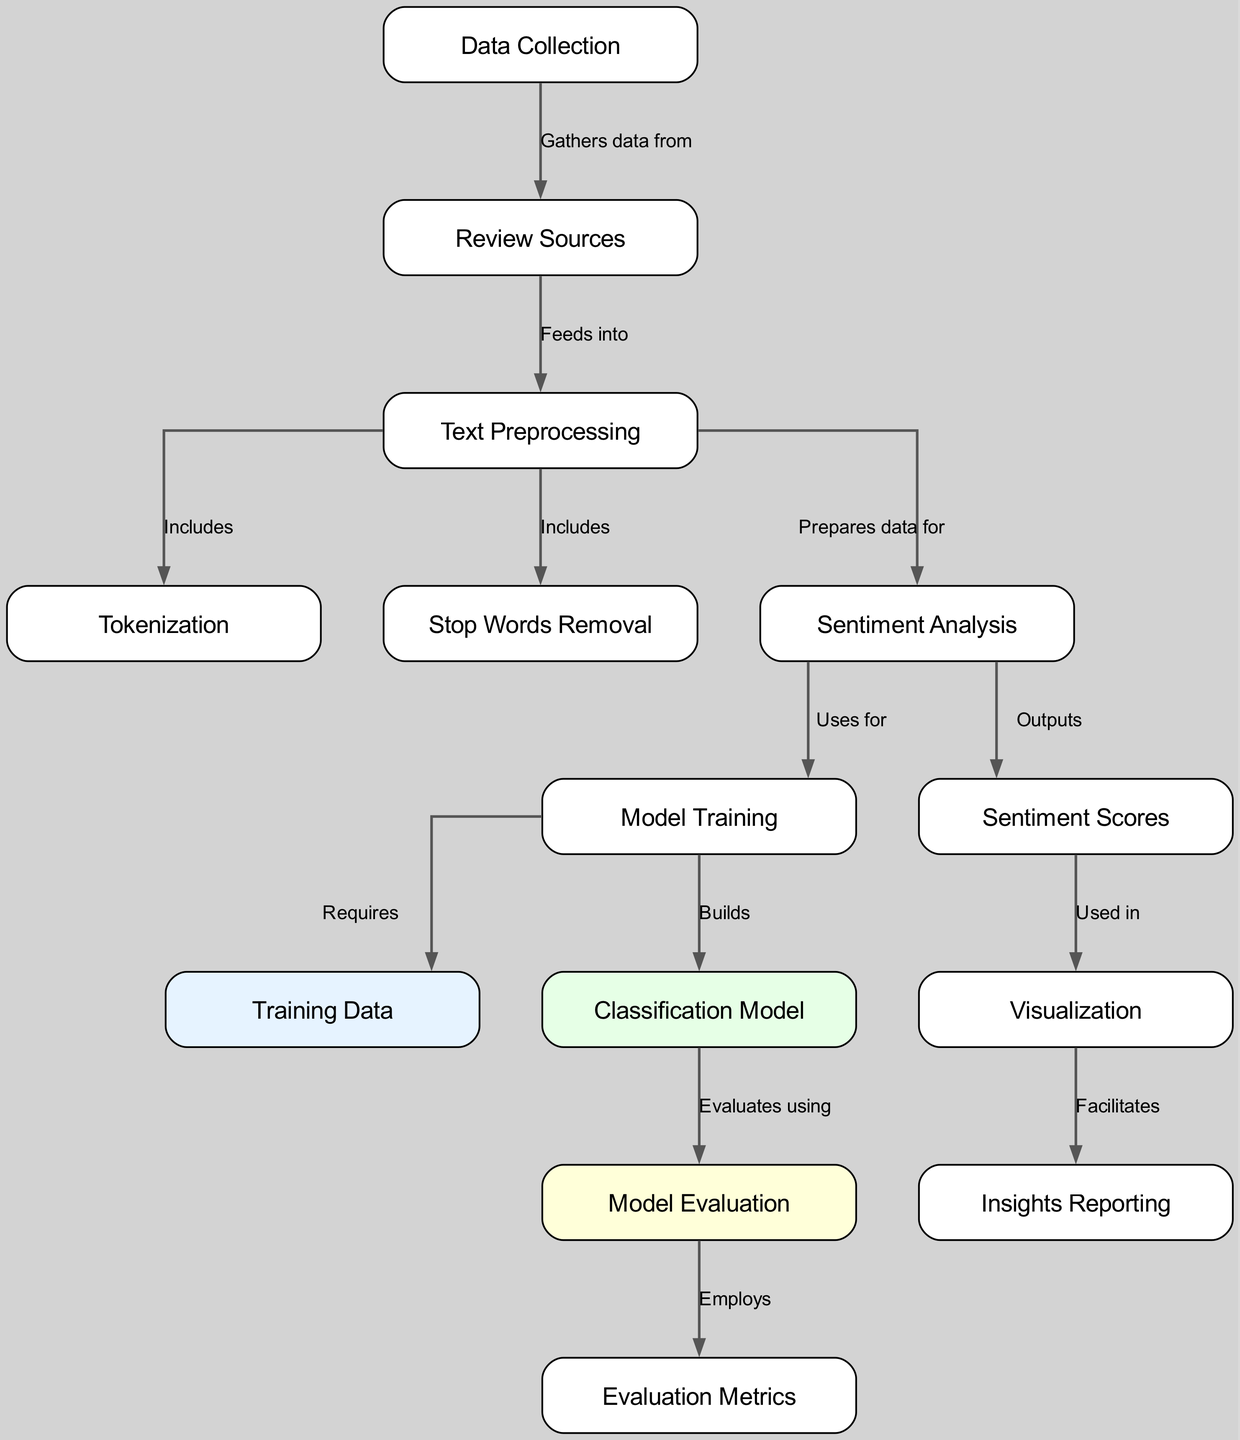What are the sources for the reviews? The node labeled "Review Sources" in the diagram indicates where the data is being gathered from for the analysis
Answer: Review Sources Which process precedes sentiment analysis? The flow from the node "Text Preprocessing" to "Sentiment Analysis" shows that text preprocessing is a necessary step before performing sentiment analysis
Answer: Text Preprocessing How many edges are in the diagram? By counting the connections (edges) between the nodes, there is a total of 13 edges indicated in the diagram
Answer: 13 What does sentiment analysis use for model training? The diagram indicates that sentiment analysis is the input or source that is utilized for model training as shown by the connection between the two nodes
Answer: Sentiment Analysis What type of output is received after sentiment analysis? The node "Sentiment Scores" directly follows sentiment analysis, indicating that it is the primary output of that process
Answer: Sentiment Scores Which step prepares data for sentiment analysis? The diagram specifies that "Text Preprocessing" is the step that prepares the collected data for the next phase, which is sentiment analysis
Answer: Text Preprocessing What facilitates insights reporting in the diagram? The connection from "Visualization" to "Insights Reporting" highlights that visualization helps in generating insights for reporting
Answer: Visualization What is included in the text preprocessing step? The diagram shows that "Tokenization" and "Stop Words Removal" are both processes included within the "Text Preprocessing" node
Answer: Tokenization and Stop Words Removal Which model is built during model training? According to the flow from "Model Training," the output is explicitly labeled as the "Classification Model," which is constructed during this stage
Answer: Classification Model 